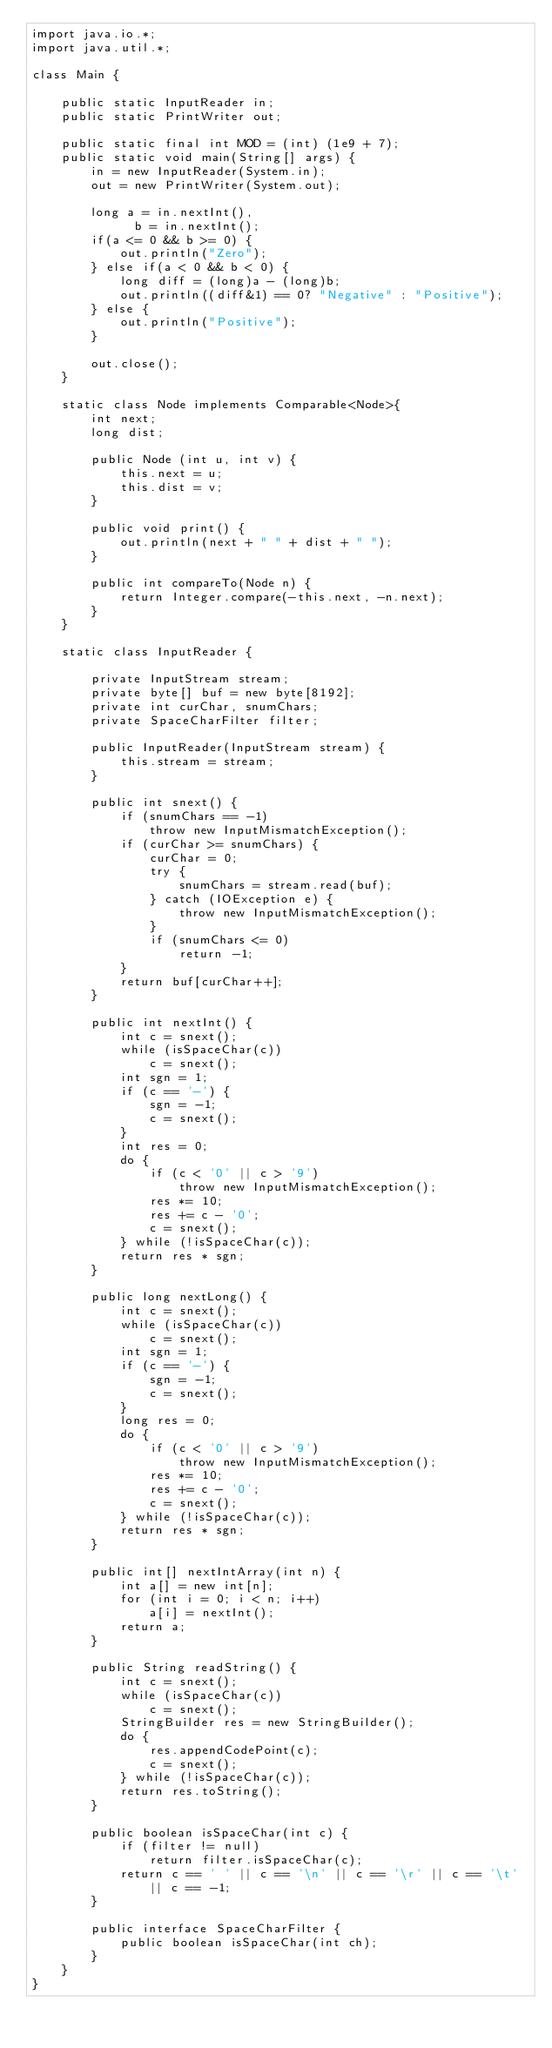Convert code to text. <code><loc_0><loc_0><loc_500><loc_500><_Java_>import java.io.*;
import java.util.*;

class Main {

    public static InputReader in;
    public static PrintWriter out;
    
    public static final int MOD = (int) (1e9 + 7);
    public static void main(String[] args) {
        in = new InputReader(System.in);
        out = new PrintWriter(System.out);
        
        long a = in.nextInt(),
              b = in.nextInt();
        if(a <= 0 && b >= 0) {
            out.println("Zero");
        } else if(a < 0 && b < 0) {
            long diff = (long)a - (long)b;
            out.println((diff&1) == 0? "Negative" : "Positive");
        } else {
            out.println("Positive");
        }
        
        out.close();
    }
    
    static class Node implements Comparable<Node>{
        int next;
        long dist;
        
        public Node (int u, int v) {
            this.next = u;
            this.dist = v;
        }
        
        public void print() {
            out.println(next + " " + dist + " ");
        }
        
        public int compareTo(Node n) {
            return Integer.compare(-this.next, -n.next);
        }
    }
    
    static class InputReader {

        private InputStream stream;
        private byte[] buf = new byte[8192];
        private int curChar, snumChars;
        private SpaceCharFilter filter;

        public InputReader(InputStream stream) {
            this.stream = stream;
        }

        public int snext() {
            if (snumChars == -1)
                throw new InputMismatchException();
            if (curChar >= snumChars) {
                curChar = 0;
                try {
                    snumChars = stream.read(buf);
                } catch (IOException e) {
                    throw new InputMismatchException();
                }
                if (snumChars <= 0)
                    return -1;
            }
            return buf[curChar++];
        }

        public int nextInt() {
            int c = snext();
            while (isSpaceChar(c))
                c = snext();
            int sgn = 1;
            if (c == '-') {
                sgn = -1;
                c = snext();
            }
            int res = 0;
            do {
                if (c < '0' || c > '9')
                    throw new InputMismatchException();
                res *= 10;
                res += c - '0';
                c = snext();
            } while (!isSpaceChar(c));
            return res * sgn;
        }

        public long nextLong() {
            int c = snext();
            while (isSpaceChar(c))
                c = snext();
            int sgn = 1;
            if (c == '-') {
                sgn = -1;
                c = snext();
            }
            long res = 0;
            do {
                if (c < '0' || c > '9')
                    throw new InputMismatchException();
                res *= 10;
                res += c - '0';
                c = snext();
            } while (!isSpaceChar(c));
            return res * sgn;
        }

        public int[] nextIntArray(int n) {
            int a[] = new int[n];
            for (int i = 0; i < n; i++)
                a[i] = nextInt();
            return a;
        }

        public String readString() {
            int c = snext();
            while (isSpaceChar(c))
                c = snext();
            StringBuilder res = new StringBuilder();
            do {
                res.appendCodePoint(c);
                c = snext();
            } while (!isSpaceChar(c));
            return res.toString();
        }

        public boolean isSpaceChar(int c) {
            if (filter != null)
                return filter.isSpaceChar(c);
            return c == ' ' || c == '\n' || c == '\r' || c == '\t' || c == -1;
        }

        public interface SpaceCharFilter {
            public boolean isSpaceChar(int ch);
        }
    }
}</code> 